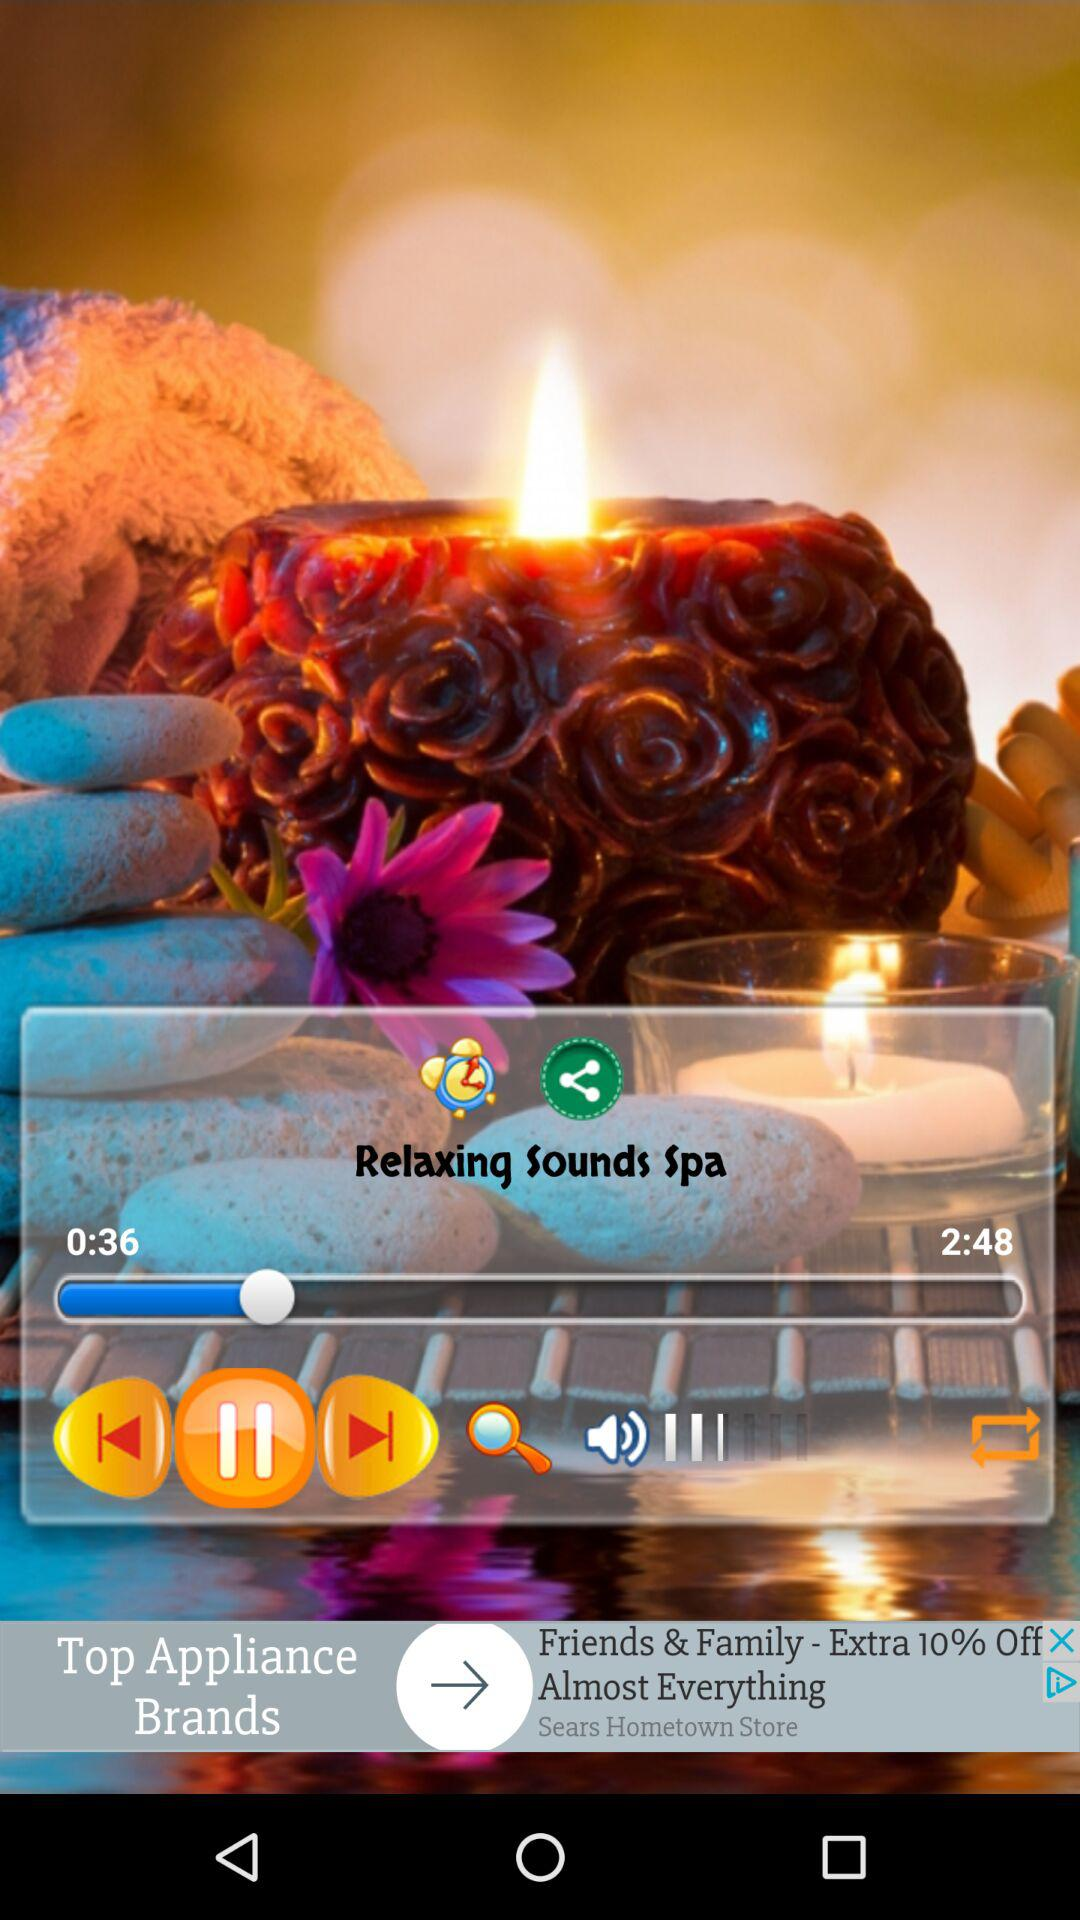What is the length of the relaxing sound? The length of the relaxing sound is 2 minutes 48 seconds. 